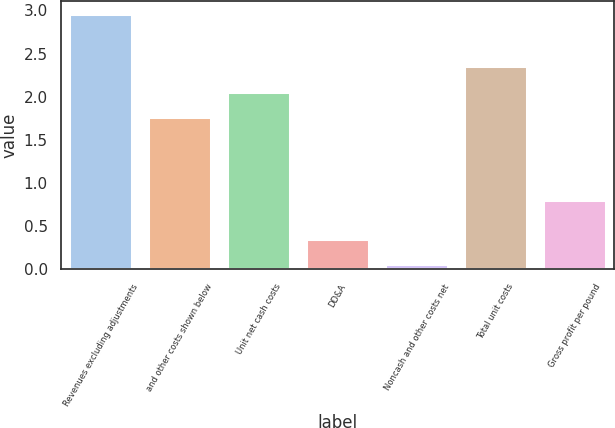Convert chart. <chart><loc_0><loc_0><loc_500><loc_500><bar_chart><fcel>Revenues excluding adjustments<fcel>and other costs shown below<fcel>Unit net cash costs<fcel>DD&A<fcel>Noncash and other costs net<fcel>Total unit costs<fcel>Gross profit per pound<nl><fcel>2.96<fcel>1.77<fcel>2.06<fcel>0.35<fcel>0.06<fcel>2.35<fcel>0.8<nl></chart> 